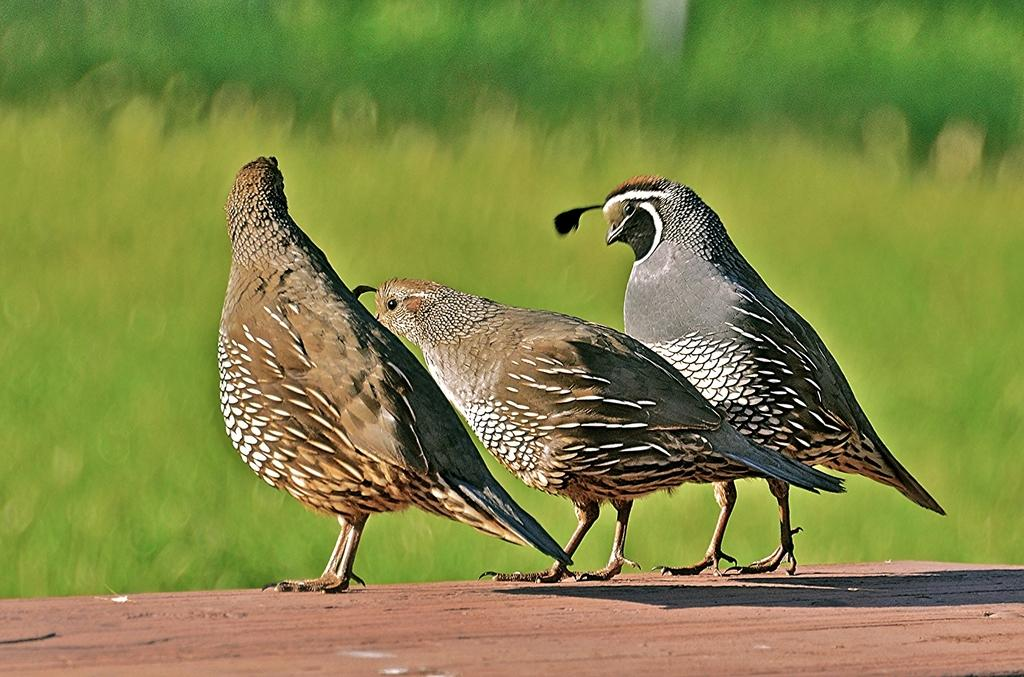How many birds can be seen in the image? There are 3 birds in the image. What is the color of the surface where the birds are standing? The birds are on a brown color surface. What color is the background of the image? The background of the image is green. How would you describe the clarity of the image? The image appears to be slightly blurry. What time is displayed on the clock in the image? There is no clock present in the image, so it is not possible to determine the time. 